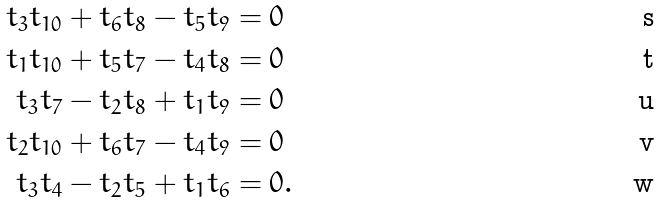Convert formula to latex. <formula><loc_0><loc_0><loc_500><loc_500>t _ { 3 } t _ { 1 0 } + t _ { 6 } t _ { 8 } - t _ { 5 } t _ { 9 } & = 0 \\ t _ { 1 } t _ { 1 0 } + t _ { 5 } t _ { 7 } - t _ { 4 } t _ { 8 } & = 0 \\ t _ { 3 } t _ { 7 } - t _ { 2 } t _ { 8 } + t _ { 1 } t _ { 9 } & = 0 \\ t _ { 2 } t _ { 1 0 } + t _ { 6 } t _ { 7 } - t _ { 4 } t _ { 9 } & = 0 \\ t _ { 3 } t _ { 4 } - t _ { 2 } t _ { 5 } + t _ { 1 } t _ { 6 } & = 0 .</formula> 